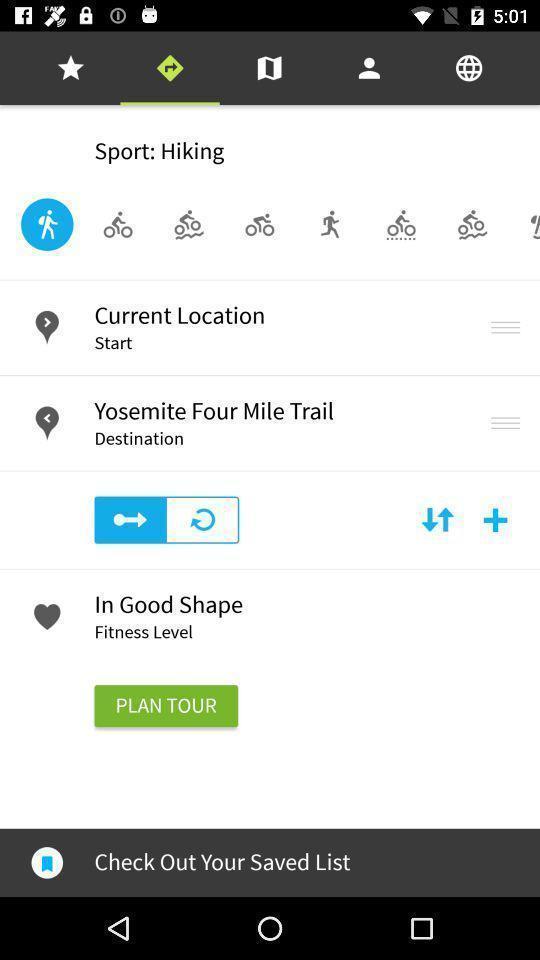Provide a detailed account of this screenshot. Page displaying directions. 